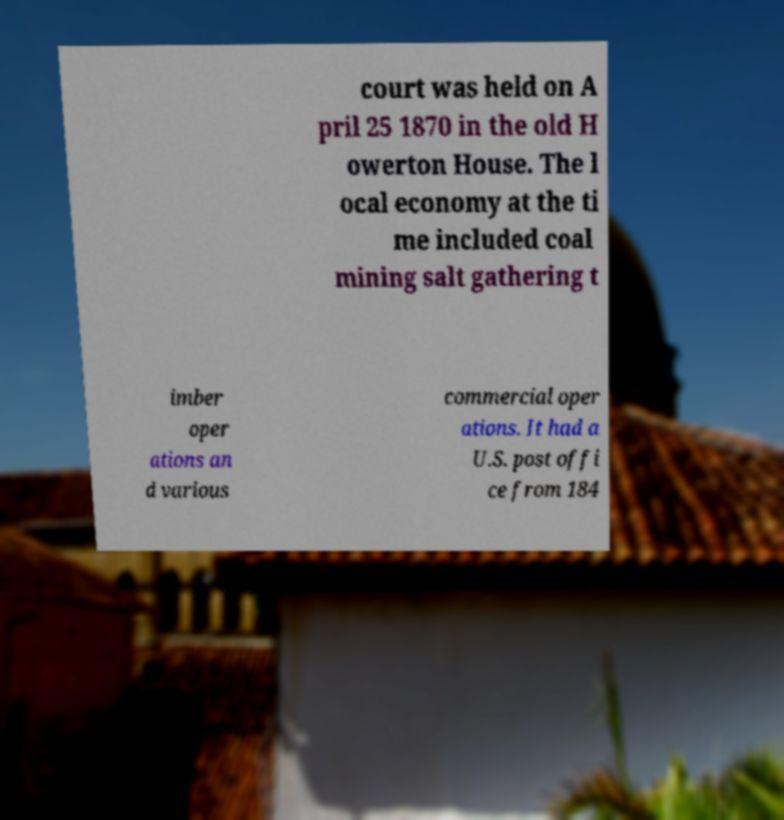What messages or text are displayed in this image? I need them in a readable, typed format. court was held on A pril 25 1870 in the old H owerton House. The l ocal economy at the ti me included coal mining salt gathering t imber oper ations an d various commercial oper ations. It had a U.S. post offi ce from 184 